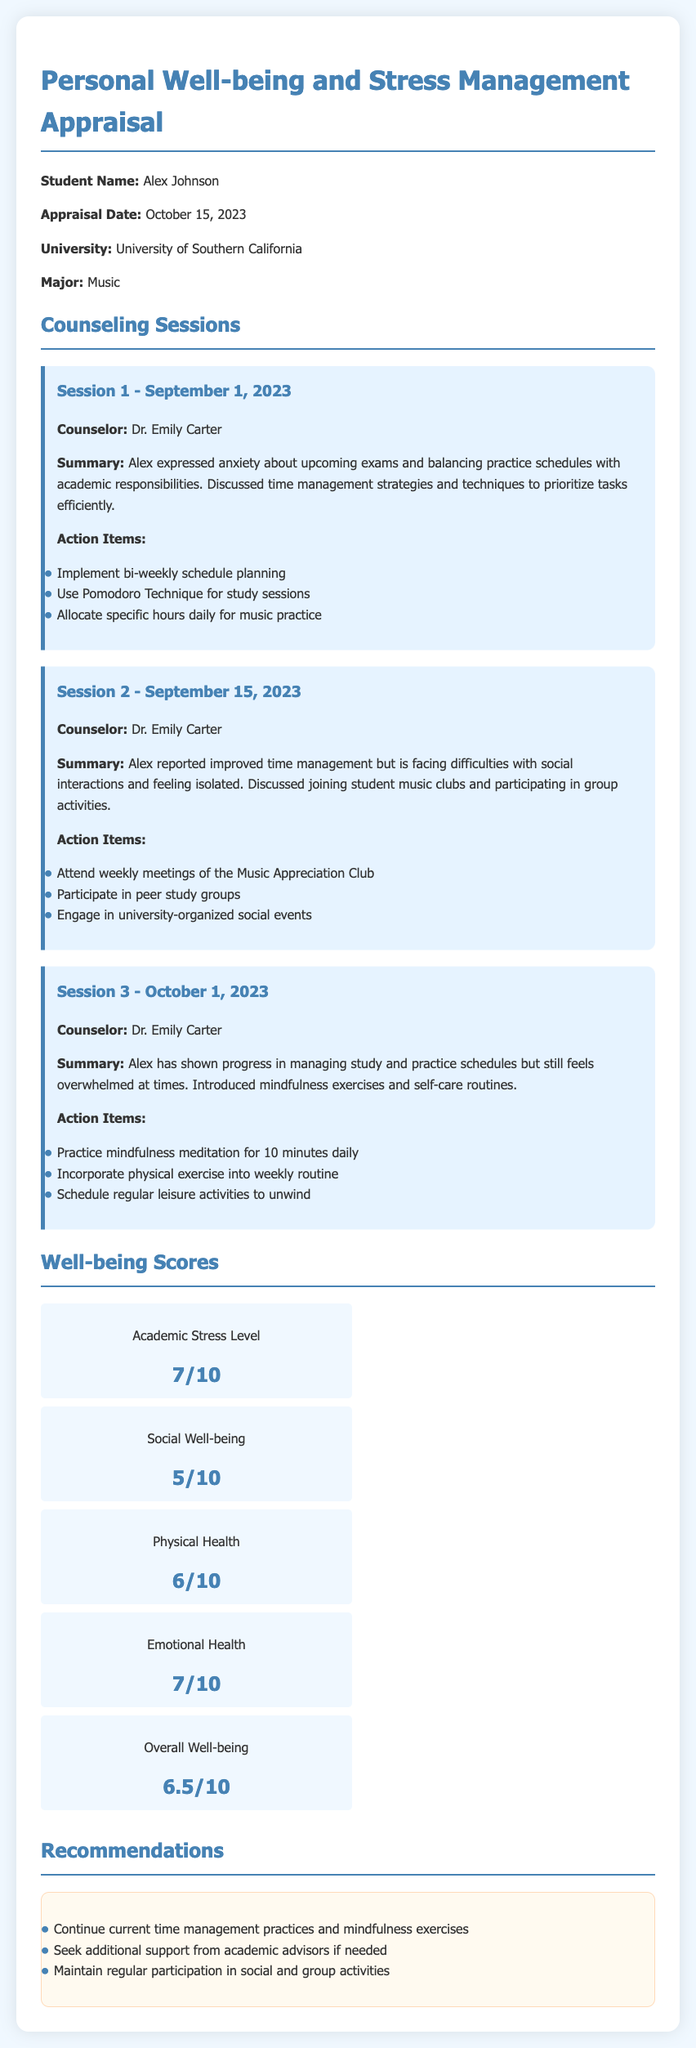What is the student's name? The student's name is stated clearly at the beginning of the document.
Answer: Alex Johnson What is the major of the student? The student's major is mentioned in the introductory section of the document.
Answer: Music Who is the counselor for the sessions? The name of the counselor is consistently provided throughout the counseling session summaries.
Answer: Dr. Emily Carter What score did Alex receive for Social Well-being? The social well-being score is listed under the well-being scores section of the document.
Answer: 5/10 What was discussed in Session 2? The summary of Session 2 provides insights into the topics discussed during that counseling session.
Answer: Difficulties with social interactions and feeling isolated What action item was suggested for Session 1? Action items from each session are listed, reflecting the focus of each counseling session.
Answer: Implement bi-weekly schedule planning What is the overall well-being score? The overall well-being score is clearly indicated among other well-being scores.
Answer: 6.5/10 How many sessions were conducted before the appraisal date? The number of sessions can be determined by counting the sessions detailed in the document.
Answer: 3 What type of recommendations are provided? The recommendations section categorizes the suggestions based on the information gathered during counseling.
Answer: Maintain regular participation in social and group activities 